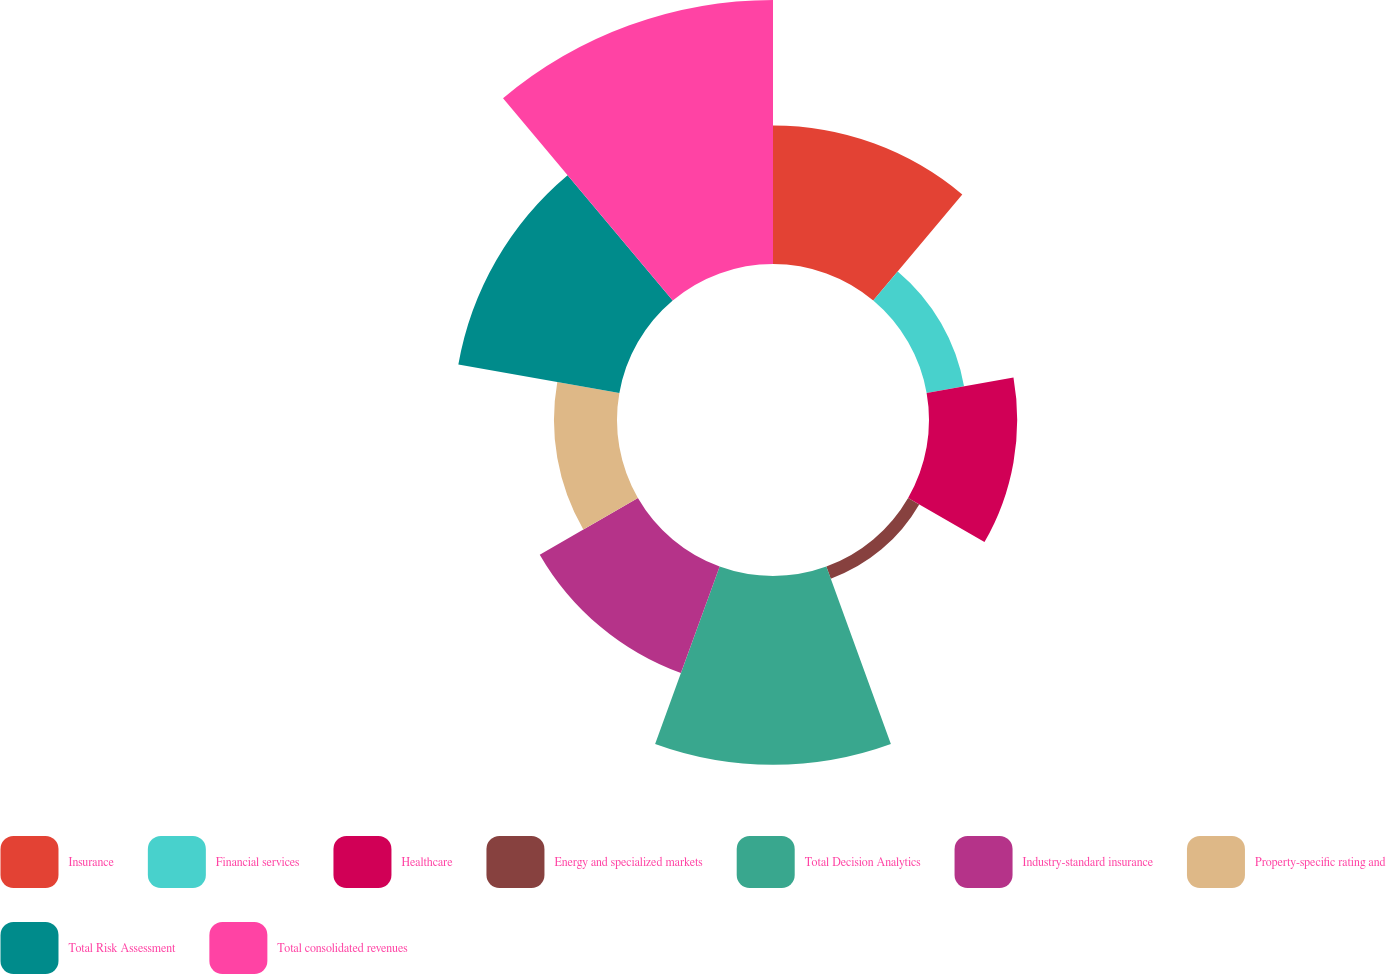Convert chart to OTSL. <chart><loc_0><loc_0><loc_500><loc_500><pie_chart><fcel>Insurance<fcel>Financial services<fcel>Healthcare<fcel>Energy and specialized markets<fcel>Total Decision Analytics<fcel>Industry-standard insurance<fcel>Property-specific rating and<fcel>Total Risk Assessment<fcel>Total consolidated revenues<nl><fcel>12.94%<fcel>3.55%<fcel>8.24%<fcel>1.2%<fcel>17.63%<fcel>10.59%<fcel>5.89%<fcel>15.28%<fcel>24.67%<nl></chart> 